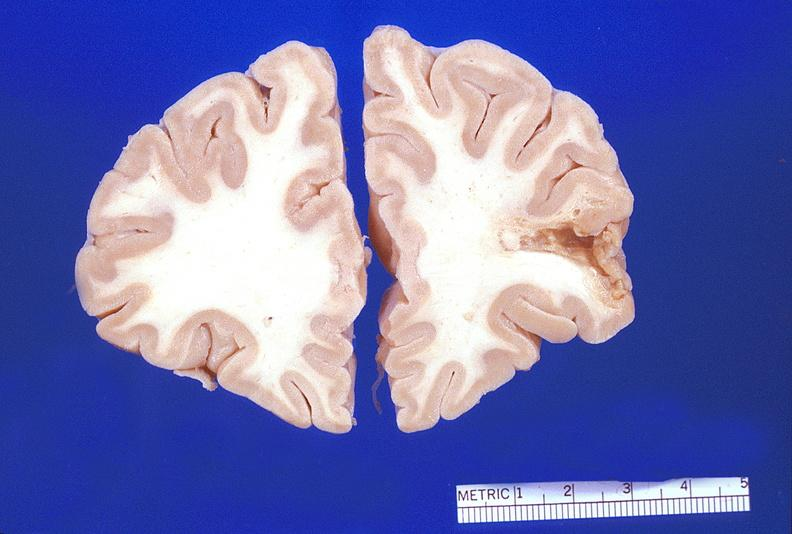does peritoneum show brain, encephalomalacia?
Answer the question using a single word or phrase. No 